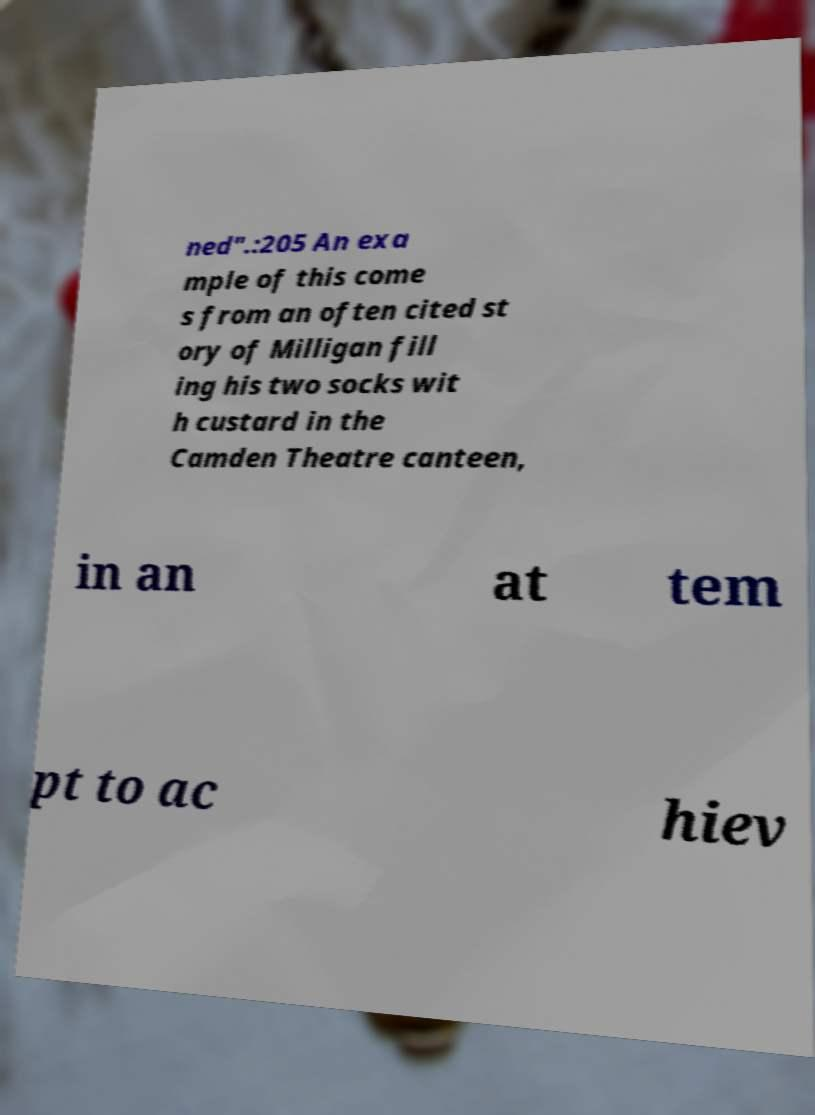For documentation purposes, I need the text within this image transcribed. Could you provide that? ned".:205 An exa mple of this come s from an often cited st ory of Milligan fill ing his two socks wit h custard in the Camden Theatre canteen, in an at tem pt to ac hiev 